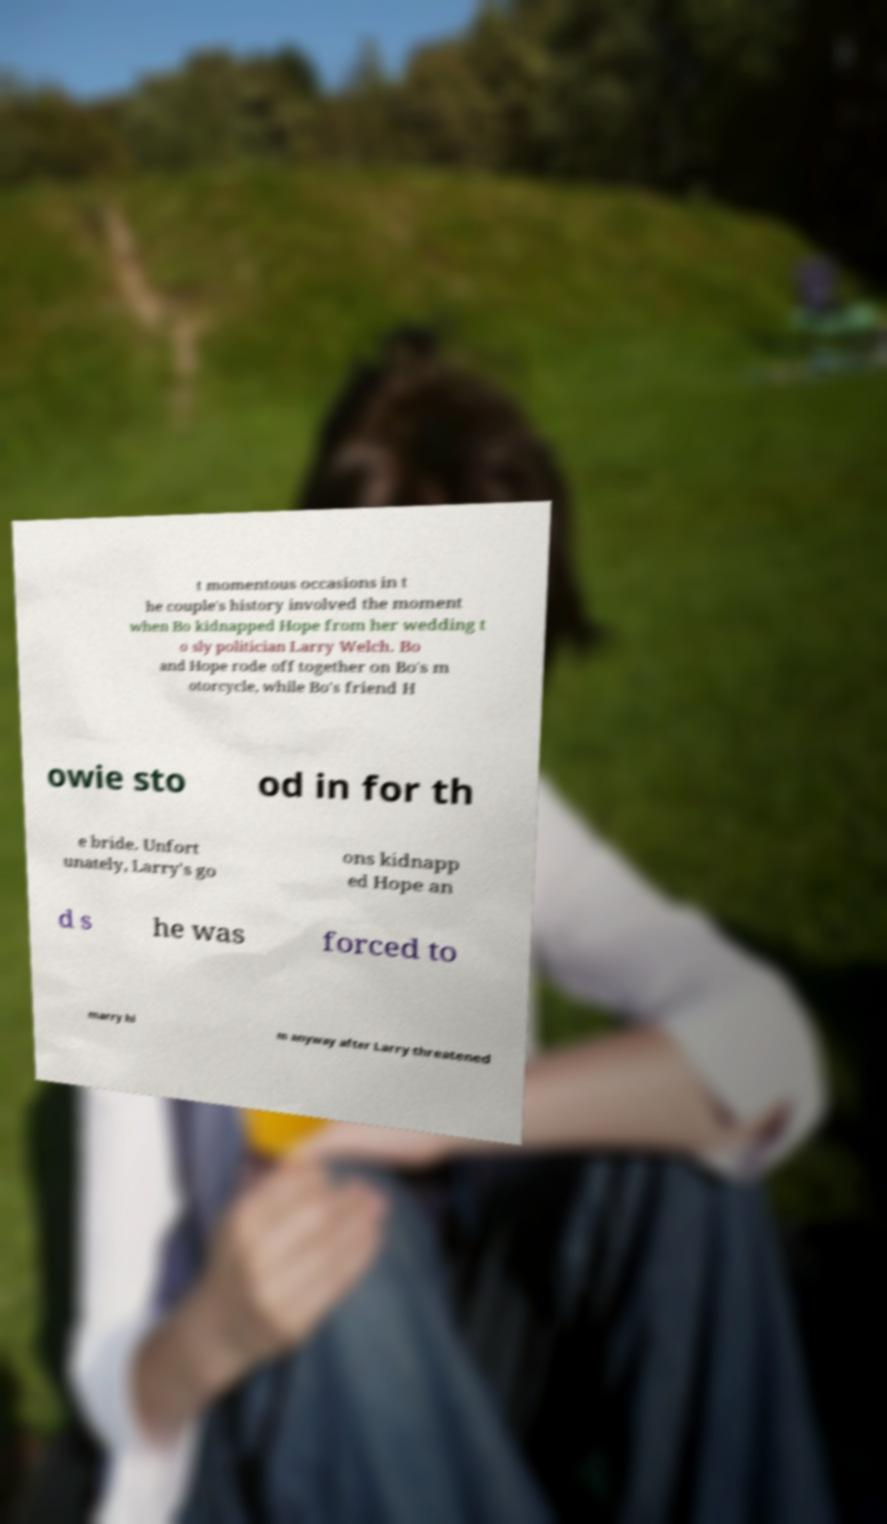Could you extract and type out the text from this image? t momentous occasions in t he couple's history involved the moment when Bo kidnapped Hope from her wedding t o sly politician Larry Welch. Bo and Hope rode off together on Bo's m otorcycle, while Bo's friend H owie sto od in for th e bride. Unfort unately, Larry's go ons kidnapp ed Hope an d s he was forced to marry hi m anyway after Larry threatened 